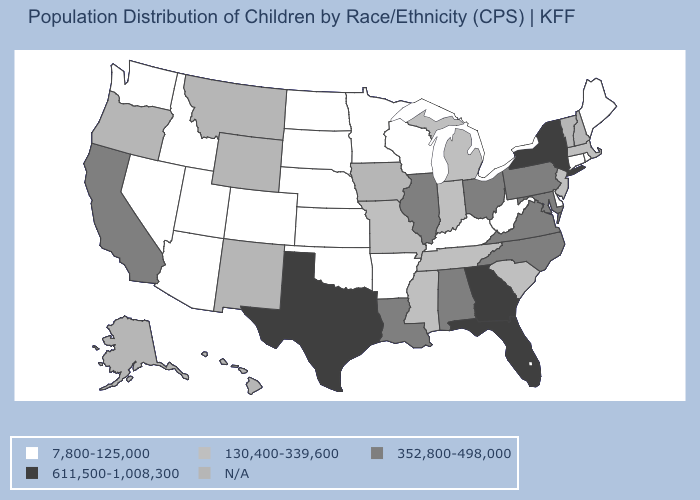Name the states that have a value in the range 352,800-498,000?
Give a very brief answer. Alabama, California, Illinois, Louisiana, Maryland, North Carolina, Ohio, Pennsylvania, Virginia. Which states have the lowest value in the USA?
Concise answer only. Arizona, Arkansas, Colorado, Connecticut, Delaware, Idaho, Kansas, Kentucky, Maine, Minnesota, Nebraska, Nevada, North Dakota, Oklahoma, Rhode Island, South Dakota, Utah, Washington, West Virginia, Wisconsin. Which states have the lowest value in the USA?
Be succinct. Arizona, Arkansas, Colorado, Connecticut, Delaware, Idaho, Kansas, Kentucky, Maine, Minnesota, Nebraska, Nevada, North Dakota, Oklahoma, Rhode Island, South Dakota, Utah, Washington, West Virginia, Wisconsin. What is the value of New Mexico?
Quick response, please. N/A. What is the value of Colorado?
Give a very brief answer. 7,800-125,000. What is the value of Virginia?
Give a very brief answer. 352,800-498,000. What is the value of Ohio?
Quick response, please. 352,800-498,000. Name the states that have a value in the range 130,400-339,600?
Give a very brief answer. Indiana, Massachusetts, Michigan, Mississippi, Missouri, New Jersey, South Carolina, Tennessee. Name the states that have a value in the range N/A?
Be succinct. Alaska, Hawaii, Iowa, Montana, New Hampshire, New Mexico, Oregon, Vermont, Wyoming. Name the states that have a value in the range 130,400-339,600?
Be succinct. Indiana, Massachusetts, Michigan, Mississippi, Missouri, New Jersey, South Carolina, Tennessee. What is the value of California?
Write a very short answer. 352,800-498,000. Which states have the lowest value in the USA?
Write a very short answer. Arizona, Arkansas, Colorado, Connecticut, Delaware, Idaho, Kansas, Kentucky, Maine, Minnesota, Nebraska, Nevada, North Dakota, Oklahoma, Rhode Island, South Dakota, Utah, Washington, West Virginia, Wisconsin. Name the states that have a value in the range 7,800-125,000?
Be succinct. Arizona, Arkansas, Colorado, Connecticut, Delaware, Idaho, Kansas, Kentucky, Maine, Minnesota, Nebraska, Nevada, North Dakota, Oklahoma, Rhode Island, South Dakota, Utah, Washington, West Virginia, Wisconsin. What is the value of Minnesota?
Short answer required. 7,800-125,000. 